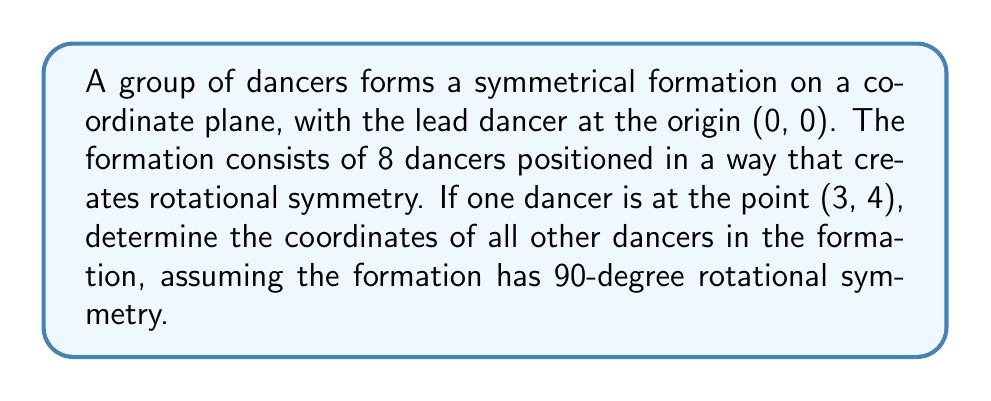Could you help me with this problem? To analyze this dance formation using coordinate transformations, we'll follow these steps:

1) First, we need to understand that 90-degree rotational symmetry means the formation repeats every quarter turn (90 degrees) around the origin.

2) We're given that one dancer is at (3, 4). Let's call this position A.

3) To find the other positions, we'll use the 90-degree rotation matrix:

   $$R_{90} = \begin{pmatrix} 
   \cos 90° & -\sin 90° \\
   \sin 90° & \cos 90°
   \end{pmatrix} = \begin{pmatrix}
   0 & -1 \\
   1 & 0
   \end{pmatrix}$$

4) Applying this rotation to position A (3, 4):

   $$\begin{pmatrix}
   0 & -1 \\
   1 & 0
   \end{pmatrix} \begin{pmatrix}
   3 \\
   4
   \end{pmatrix} = \begin{pmatrix}
   -4 \\
   3
   \end{pmatrix}$$

   This gives us position B: (-4, 3)

5) Rotating again by 90 degrees:

   $$\begin{pmatrix}
   0 & -1 \\
   1 & 0
   \end{pmatrix} \begin{pmatrix}
   -4 \\
   3
   \end{pmatrix} = \begin{pmatrix}
   -3 \\
   -4
   \end{pmatrix}$$

   This gives us position C: (-3, -4)

6) Rotating one more time:

   $$\begin{pmatrix}
   0 & -1 \\
   1 & 0
   \end{pmatrix} \begin{pmatrix}
   -3 \\
   -4
   \end{pmatrix} = \begin{pmatrix}
   4 \\
   -3
   \end{pmatrix}$$

   This gives us position D: (4, -3)

7) The next 90-degree rotation would bring us back to position A, completing the cycle.

Therefore, the 8 dancers in the formation are at these coordinates:
- Lead dancer: (0, 0)
- Dancer A: (3, 4)
- Dancer B: (-4, 3)
- Dancer C: (-3, -4)
- Dancer D: (4, -3)
- And their midpoints:
  - Between A and B: (-0.5, 3.5)
  - Between B and C: (-3.5, -0.5)
  - Between C and D: (0.5, -3.5)
  - Between D and A: (3.5, 0.5)
Answer: The coordinates of all dancers in the formation are:
(0, 0), (3, 4), (-4, 3), (-3, -4), (4, -3), (-0.5, 3.5), (-3.5, -0.5), (0.5, -3.5), (3.5, 0.5) 